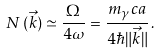Convert formula to latex. <formula><loc_0><loc_0><loc_500><loc_500>N \, ( \vec { k } ) \simeq \frac { \Omega } { 4 \omega } = \frac { m _ { \gamma } c a } { 4 \hbar { \| } \vec { k } \| } \, .</formula> 